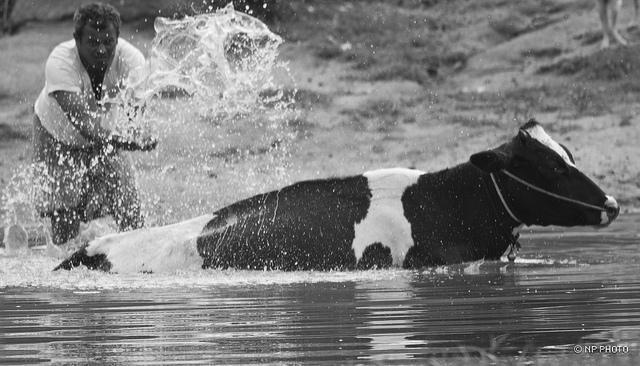How many surfboards are there?
Give a very brief answer. 0. 